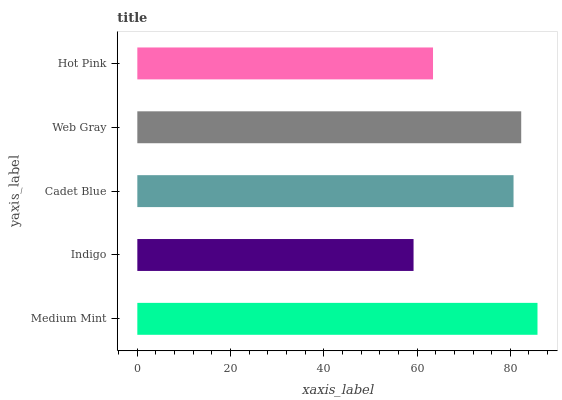Is Indigo the minimum?
Answer yes or no. Yes. Is Medium Mint the maximum?
Answer yes or no. Yes. Is Cadet Blue the minimum?
Answer yes or no. No. Is Cadet Blue the maximum?
Answer yes or no. No. Is Cadet Blue greater than Indigo?
Answer yes or no. Yes. Is Indigo less than Cadet Blue?
Answer yes or no. Yes. Is Indigo greater than Cadet Blue?
Answer yes or no. No. Is Cadet Blue less than Indigo?
Answer yes or no. No. Is Cadet Blue the high median?
Answer yes or no. Yes. Is Cadet Blue the low median?
Answer yes or no. Yes. Is Indigo the high median?
Answer yes or no. No. Is Web Gray the low median?
Answer yes or no. No. 